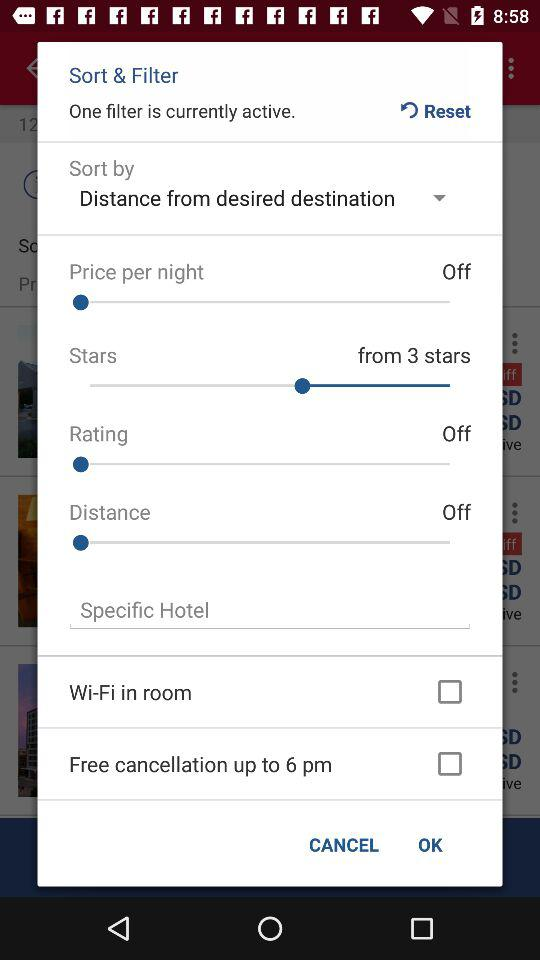Till what time is the free cancellation? The free cancellation is till 6 pm. 